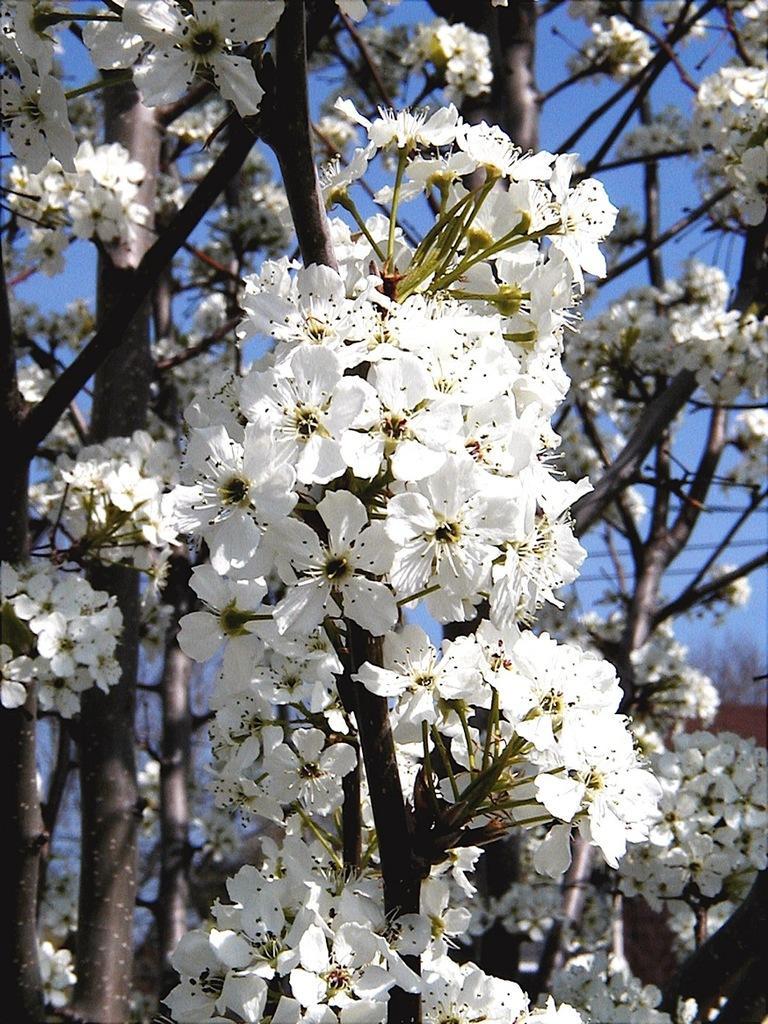In one or two sentences, can you explain what this image depicts? In the foreground of this image, there are white color flowers to a tree. In the background, there is the sky. 